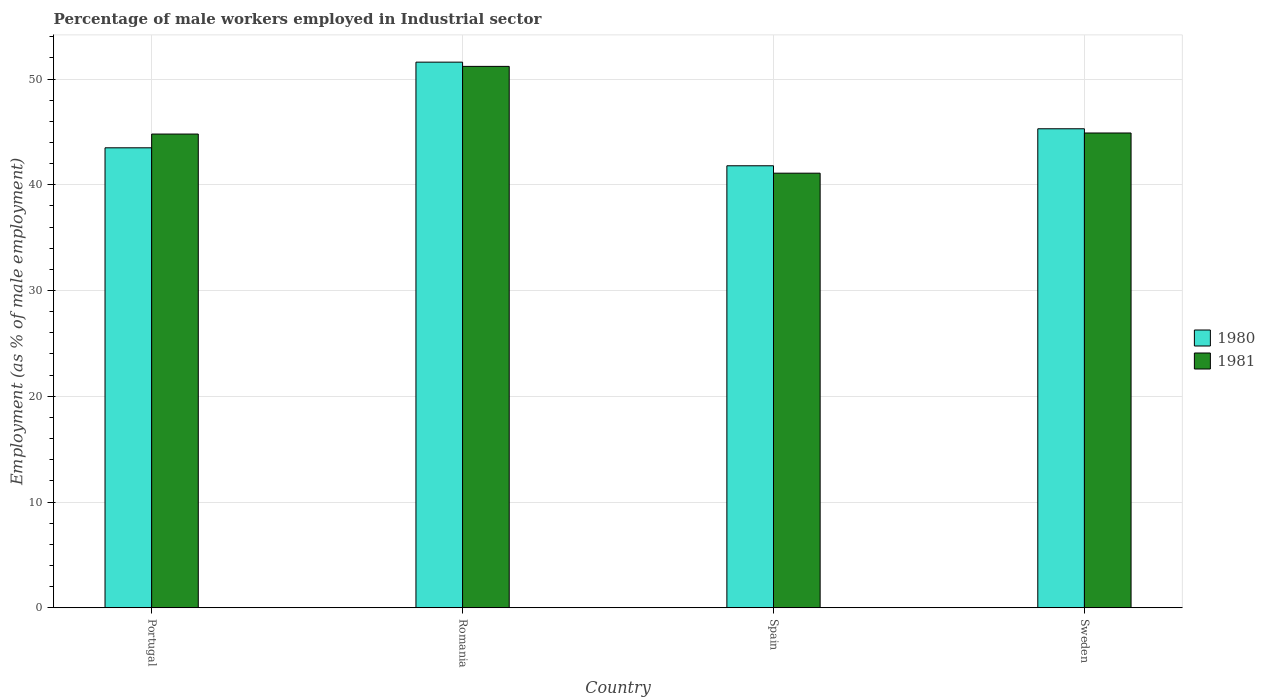Are the number of bars per tick equal to the number of legend labels?
Ensure brevity in your answer.  Yes. How many bars are there on the 1st tick from the right?
Offer a terse response. 2. What is the percentage of male workers employed in Industrial sector in 1980 in Portugal?
Offer a very short reply. 43.5. Across all countries, what is the maximum percentage of male workers employed in Industrial sector in 1980?
Your response must be concise. 51.6. Across all countries, what is the minimum percentage of male workers employed in Industrial sector in 1981?
Provide a short and direct response. 41.1. In which country was the percentage of male workers employed in Industrial sector in 1980 maximum?
Offer a very short reply. Romania. In which country was the percentage of male workers employed in Industrial sector in 1981 minimum?
Offer a terse response. Spain. What is the total percentage of male workers employed in Industrial sector in 1981 in the graph?
Your answer should be compact. 182. What is the difference between the percentage of male workers employed in Industrial sector in 1981 in Romania and that in Sweden?
Make the answer very short. 6.3. What is the difference between the percentage of male workers employed in Industrial sector in 1980 in Sweden and the percentage of male workers employed in Industrial sector in 1981 in Spain?
Offer a very short reply. 4.2. What is the average percentage of male workers employed in Industrial sector in 1981 per country?
Provide a succinct answer. 45.5. What is the difference between the percentage of male workers employed in Industrial sector of/in 1981 and percentage of male workers employed in Industrial sector of/in 1980 in Sweden?
Provide a short and direct response. -0.4. What is the ratio of the percentage of male workers employed in Industrial sector in 1980 in Portugal to that in Spain?
Provide a short and direct response. 1.04. What is the difference between the highest and the second highest percentage of male workers employed in Industrial sector in 1981?
Your answer should be very brief. 6.3. What is the difference between the highest and the lowest percentage of male workers employed in Industrial sector in 1980?
Your response must be concise. 9.8. In how many countries, is the percentage of male workers employed in Industrial sector in 1980 greater than the average percentage of male workers employed in Industrial sector in 1980 taken over all countries?
Keep it short and to the point. 1. What does the 2nd bar from the left in Spain represents?
Provide a short and direct response. 1981. How many countries are there in the graph?
Provide a succinct answer. 4. Does the graph contain grids?
Your answer should be very brief. Yes. What is the title of the graph?
Make the answer very short. Percentage of male workers employed in Industrial sector. Does "1981" appear as one of the legend labels in the graph?
Make the answer very short. Yes. What is the label or title of the Y-axis?
Your response must be concise. Employment (as % of male employment). What is the Employment (as % of male employment) in 1980 in Portugal?
Give a very brief answer. 43.5. What is the Employment (as % of male employment) of 1981 in Portugal?
Your answer should be very brief. 44.8. What is the Employment (as % of male employment) of 1980 in Romania?
Make the answer very short. 51.6. What is the Employment (as % of male employment) of 1981 in Romania?
Keep it short and to the point. 51.2. What is the Employment (as % of male employment) of 1980 in Spain?
Give a very brief answer. 41.8. What is the Employment (as % of male employment) in 1981 in Spain?
Keep it short and to the point. 41.1. What is the Employment (as % of male employment) of 1980 in Sweden?
Give a very brief answer. 45.3. What is the Employment (as % of male employment) in 1981 in Sweden?
Give a very brief answer. 44.9. Across all countries, what is the maximum Employment (as % of male employment) in 1980?
Provide a short and direct response. 51.6. Across all countries, what is the maximum Employment (as % of male employment) in 1981?
Give a very brief answer. 51.2. Across all countries, what is the minimum Employment (as % of male employment) of 1980?
Provide a short and direct response. 41.8. Across all countries, what is the minimum Employment (as % of male employment) of 1981?
Provide a short and direct response. 41.1. What is the total Employment (as % of male employment) in 1980 in the graph?
Provide a short and direct response. 182.2. What is the total Employment (as % of male employment) of 1981 in the graph?
Your response must be concise. 182. What is the difference between the Employment (as % of male employment) of 1981 in Portugal and that in Romania?
Give a very brief answer. -6.4. What is the difference between the Employment (as % of male employment) in 1980 in Portugal and that in Spain?
Your answer should be compact. 1.7. What is the difference between the Employment (as % of male employment) in 1981 in Portugal and that in Spain?
Your answer should be compact. 3.7. What is the difference between the Employment (as % of male employment) in 1980 in Romania and that in Sweden?
Ensure brevity in your answer.  6.3. What is the difference between the Employment (as % of male employment) in 1981 in Romania and that in Sweden?
Offer a very short reply. 6.3. What is the difference between the Employment (as % of male employment) of 1980 in Romania and the Employment (as % of male employment) of 1981 in Spain?
Your answer should be very brief. 10.5. What is the difference between the Employment (as % of male employment) in 1980 in Romania and the Employment (as % of male employment) in 1981 in Sweden?
Your answer should be compact. 6.7. What is the average Employment (as % of male employment) of 1980 per country?
Provide a short and direct response. 45.55. What is the average Employment (as % of male employment) of 1981 per country?
Provide a short and direct response. 45.5. What is the difference between the Employment (as % of male employment) in 1980 and Employment (as % of male employment) in 1981 in Romania?
Ensure brevity in your answer.  0.4. What is the difference between the Employment (as % of male employment) of 1980 and Employment (as % of male employment) of 1981 in Spain?
Offer a very short reply. 0.7. What is the ratio of the Employment (as % of male employment) in 1980 in Portugal to that in Romania?
Offer a terse response. 0.84. What is the ratio of the Employment (as % of male employment) in 1981 in Portugal to that in Romania?
Give a very brief answer. 0.88. What is the ratio of the Employment (as % of male employment) in 1980 in Portugal to that in Spain?
Provide a short and direct response. 1.04. What is the ratio of the Employment (as % of male employment) in 1981 in Portugal to that in Spain?
Keep it short and to the point. 1.09. What is the ratio of the Employment (as % of male employment) in 1980 in Portugal to that in Sweden?
Offer a terse response. 0.96. What is the ratio of the Employment (as % of male employment) in 1981 in Portugal to that in Sweden?
Keep it short and to the point. 1. What is the ratio of the Employment (as % of male employment) of 1980 in Romania to that in Spain?
Ensure brevity in your answer.  1.23. What is the ratio of the Employment (as % of male employment) in 1981 in Romania to that in Spain?
Your answer should be very brief. 1.25. What is the ratio of the Employment (as % of male employment) in 1980 in Romania to that in Sweden?
Keep it short and to the point. 1.14. What is the ratio of the Employment (as % of male employment) in 1981 in Romania to that in Sweden?
Keep it short and to the point. 1.14. What is the ratio of the Employment (as % of male employment) in 1980 in Spain to that in Sweden?
Provide a succinct answer. 0.92. What is the ratio of the Employment (as % of male employment) in 1981 in Spain to that in Sweden?
Provide a succinct answer. 0.92. What is the difference between the highest and the second highest Employment (as % of male employment) in 1980?
Ensure brevity in your answer.  6.3. What is the difference between the highest and the second highest Employment (as % of male employment) in 1981?
Offer a terse response. 6.3. What is the difference between the highest and the lowest Employment (as % of male employment) in 1980?
Make the answer very short. 9.8. What is the difference between the highest and the lowest Employment (as % of male employment) of 1981?
Provide a succinct answer. 10.1. 